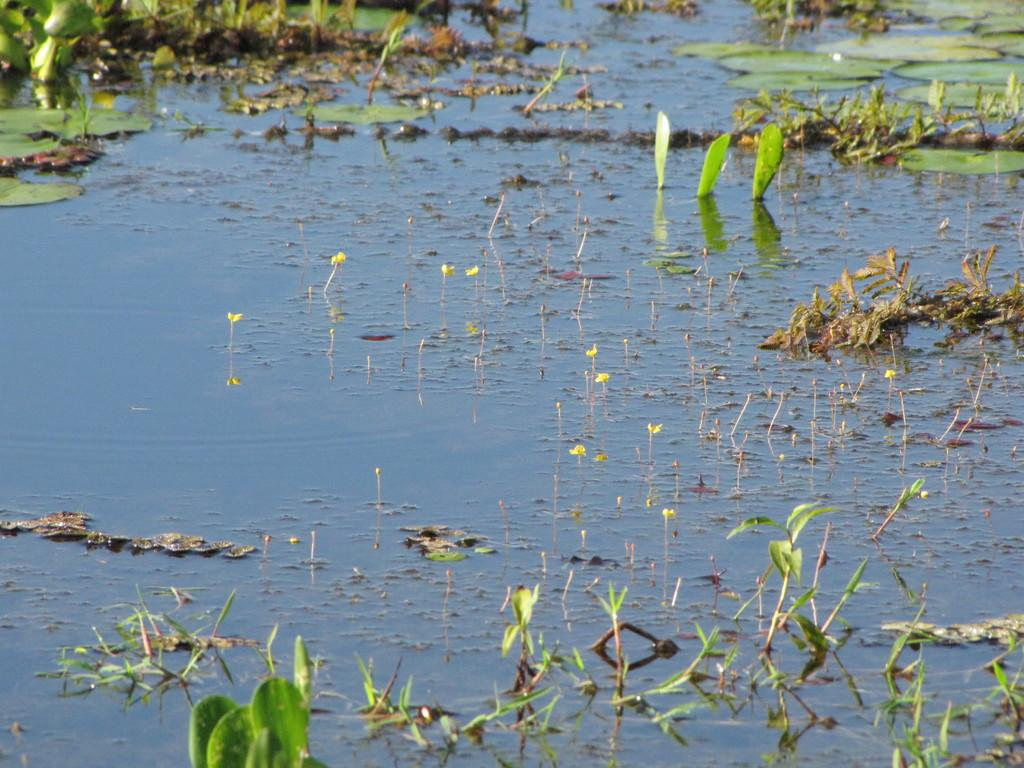What is the main subject of the image? The main subject of the image is a group of flowers. What other types of vegetation are present in the image? There are plants in the image. Where are the flowers and plants located? The flowers and plants are in the water. What type of toothbrush is being used to play the acoustics in the image? There is no toothbrush or any musical instrument present in the image, so it is not possible to determine what type of toothbrush might be used for playing acoustics. 